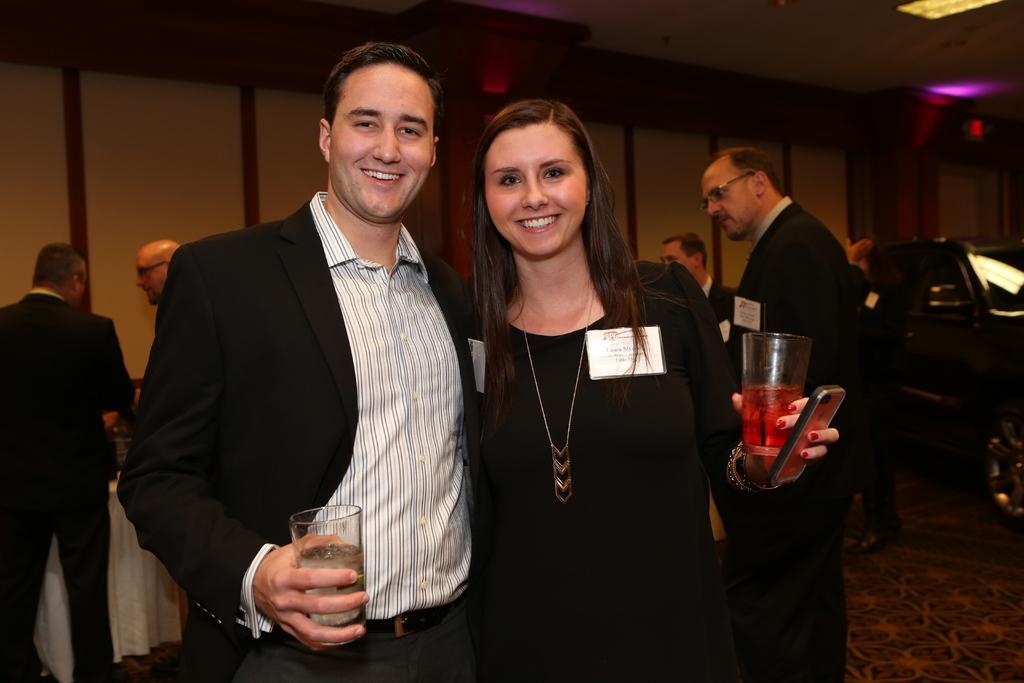Describe this image in one or two sentences. In this picture there is a woman who is wearing black dress and holding a wine glass and mobile phone. Beside her there is a man who is wearing blazer, shirt and trouser. He is holding the water glass. In the background we can see the group of persons who was standing near to the table. On the right there is a black car. In the top right corner we can see the lights. 